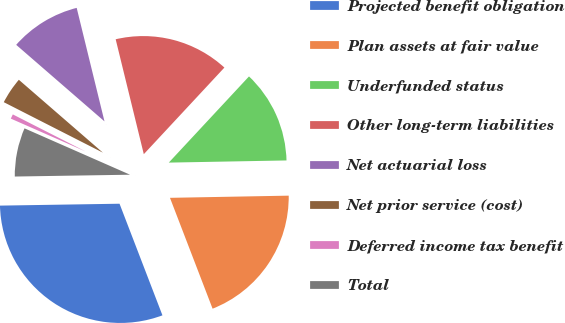Convert chart to OTSL. <chart><loc_0><loc_0><loc_500><loc_500><pie_chart><fcel>Projected benefit obligation<fcel>Plan assets at fair value<fcel>Underfunded status<fcel>Other long-term liabilities<fcel>Net actuarial loss<fcel>Net prior service (cost)<fcel>Deferred income tax benefit<fcel>Total<nl><fcel>30.59%<fcel>19.45%<fcel>12.78%<fcel>15.75%<fcel>9.81%<fcel>3.87%<fcel>0.91%<fcel>6.84%<nl></chart> 